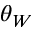<formula> <loc_0><loc_0><loc_500><loc_500>\theta _ { W }</formula> 